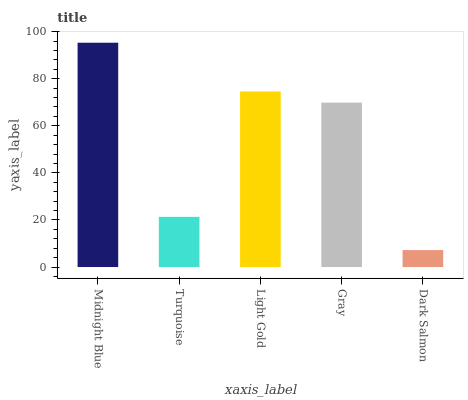Is Dark Salmon the minimum?
Answer yes or no. Yes. Is Midnight Blue the maximum?
Answer yes or no. Yes. Is Turquoise the minimum?
Answer yes or no. No. Is Turquoise the maximum?
Answer yes or no. No. Is Midnight Blue greater than Turquoise?
Answer yes or no. Yes. Is Turquoise less than Midnight Blue?
Answer yes or no. Yes. Is Turquoise greater than Midnight Blue?
Answer yes or no. No. Is Midnight Blue less than Turquoise?
Answer yes or no. No. Is Gray the high median?
Answer yes or no. Yes. Is Gray the low median?
Answer yes or no. Yes. Is Turquoise the high median?
Answer yes or no. No. Is Turquoise the low median?
Answer yes or no. No. 